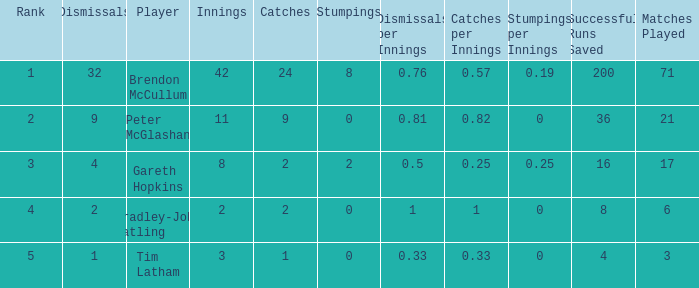Can you give me this table as a dict? {'header': ['Rank', 'Dismissals', 'Player', 'Innings', 'Catches', 'Stumpings', 'Dismissals per Innings', 'Catches per Innings', 'Stumpings per Innings', 'Successful Runs Saved', 'Matches Played'], 'rows': [['1', '32', 'Brendon McCullum', '42', '24', '8', '0.76', '0.57', '0.19', '200', '71'], ['2', '9', 'Peter McGlashan', '11', '9', '0', '0.81', '0.82', '0', '36', '21'], ['3', '4', 'Gareth Hopkins', '8', '2', '2', '0.5', '0.25', '0.25', '16', '17'], ['4', '2', 'Bradley-John Watling', '2', '2', '0', '1', '1', '0', '8', '6'], ['5', '1', 'Tim Latham', '3', '1', '0', '0.33', '0.33', '0', '4', '3']]} How many innings had a total of 2 catches and 0 stumpings? 1.0. 